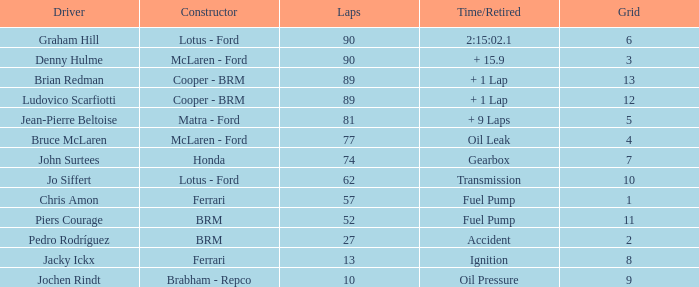What is the time/retired when the laps is 52? Fuel Pump. 